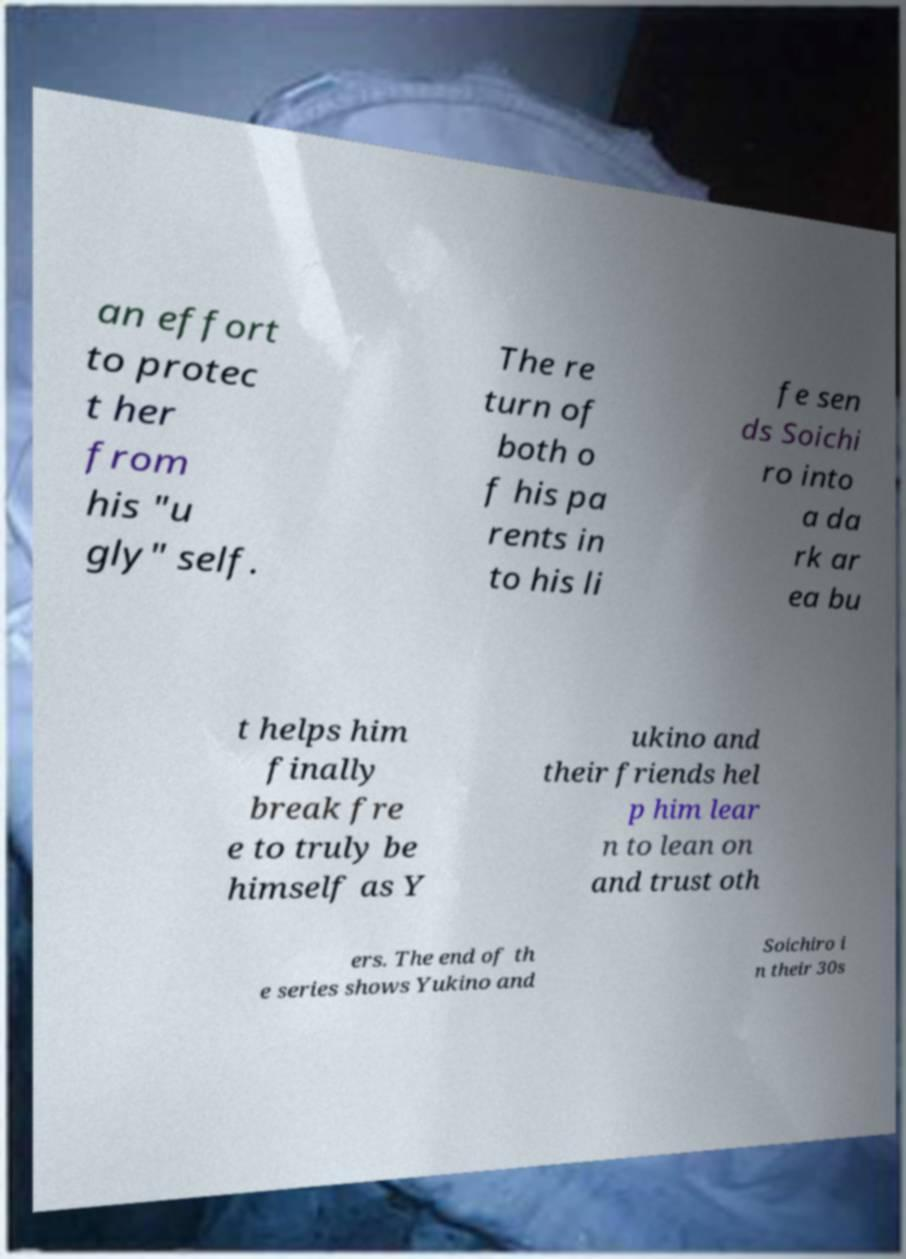Please read and relay the text visible in this image. What does it say? an effort to protec t her from his "u gly" self. The re turn of both o f his pa rents in to his li fe sen ds Soichi ro into a da rk ar ea bu t helps him finally break fre e to truly be himself as Y ukino and their friends hel p him lear n to lean on and trust oth ers. The end of th e series shows Yukino and Soichiro i n their 30s 